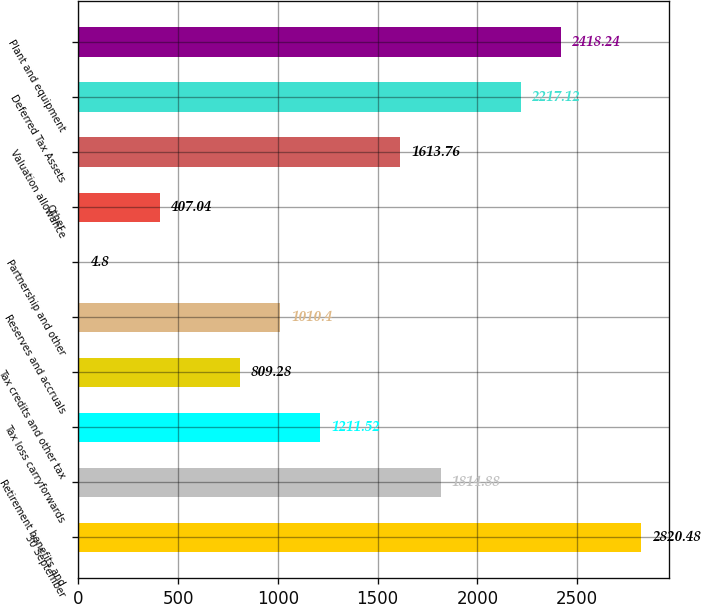Convert chart to OTSL. <chart><loc_0><loc_0><loc_500><loc_500><bar_chart><fcel>30 September<fcel>Retirement benefits and<fcel>Tax loss carryforwards<fcel>Tax credits and other tax<fcel>Reserves and accruals<fcel>Partnership and other<fcel>Other<fcel>Valuation allowance<fcel>Deferred Tax Assets<fcel>Plant and equipment<nl><fcel>2820.48<fcel>1814.88<fcel>1211.52<fcel>809.28<fcel>1010.4<fcel>4.8<fcel>407.04<fcel>1613.76<fcel>2217.12<fcel>2418.24<nl></chart> 